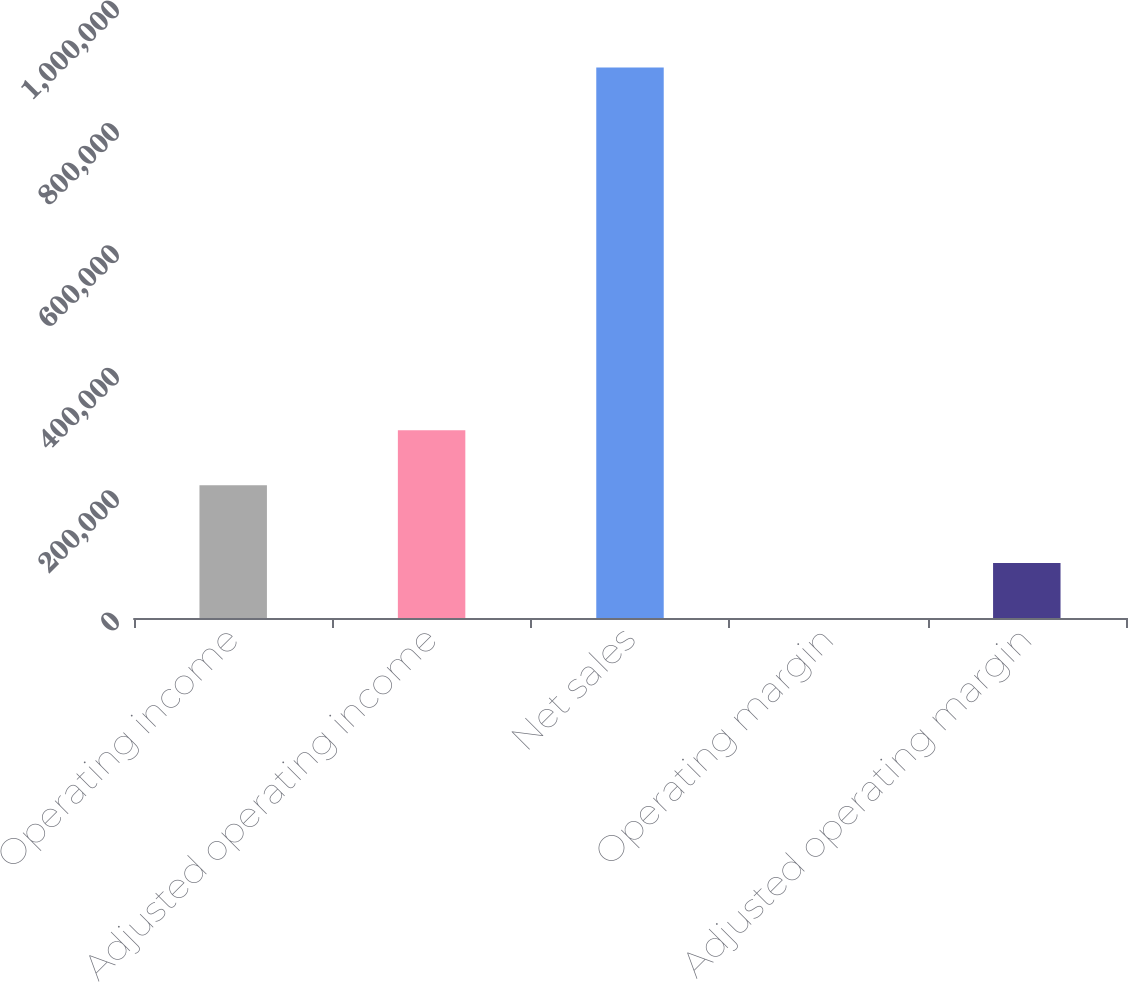Convert chart to OTSL. <chart><loc_0><loc_0><loc_500><loc_500><bar_chart><fcel>Operating income<fcel>Adjusted operating income<fcel>Net sales<fcel>Operating margin<fcel>Adjusted operating margin<nl><fcel>216886<fcel>306842<fcel>899588<fcel>24.1<fcel>89980.5<nl></chart> 